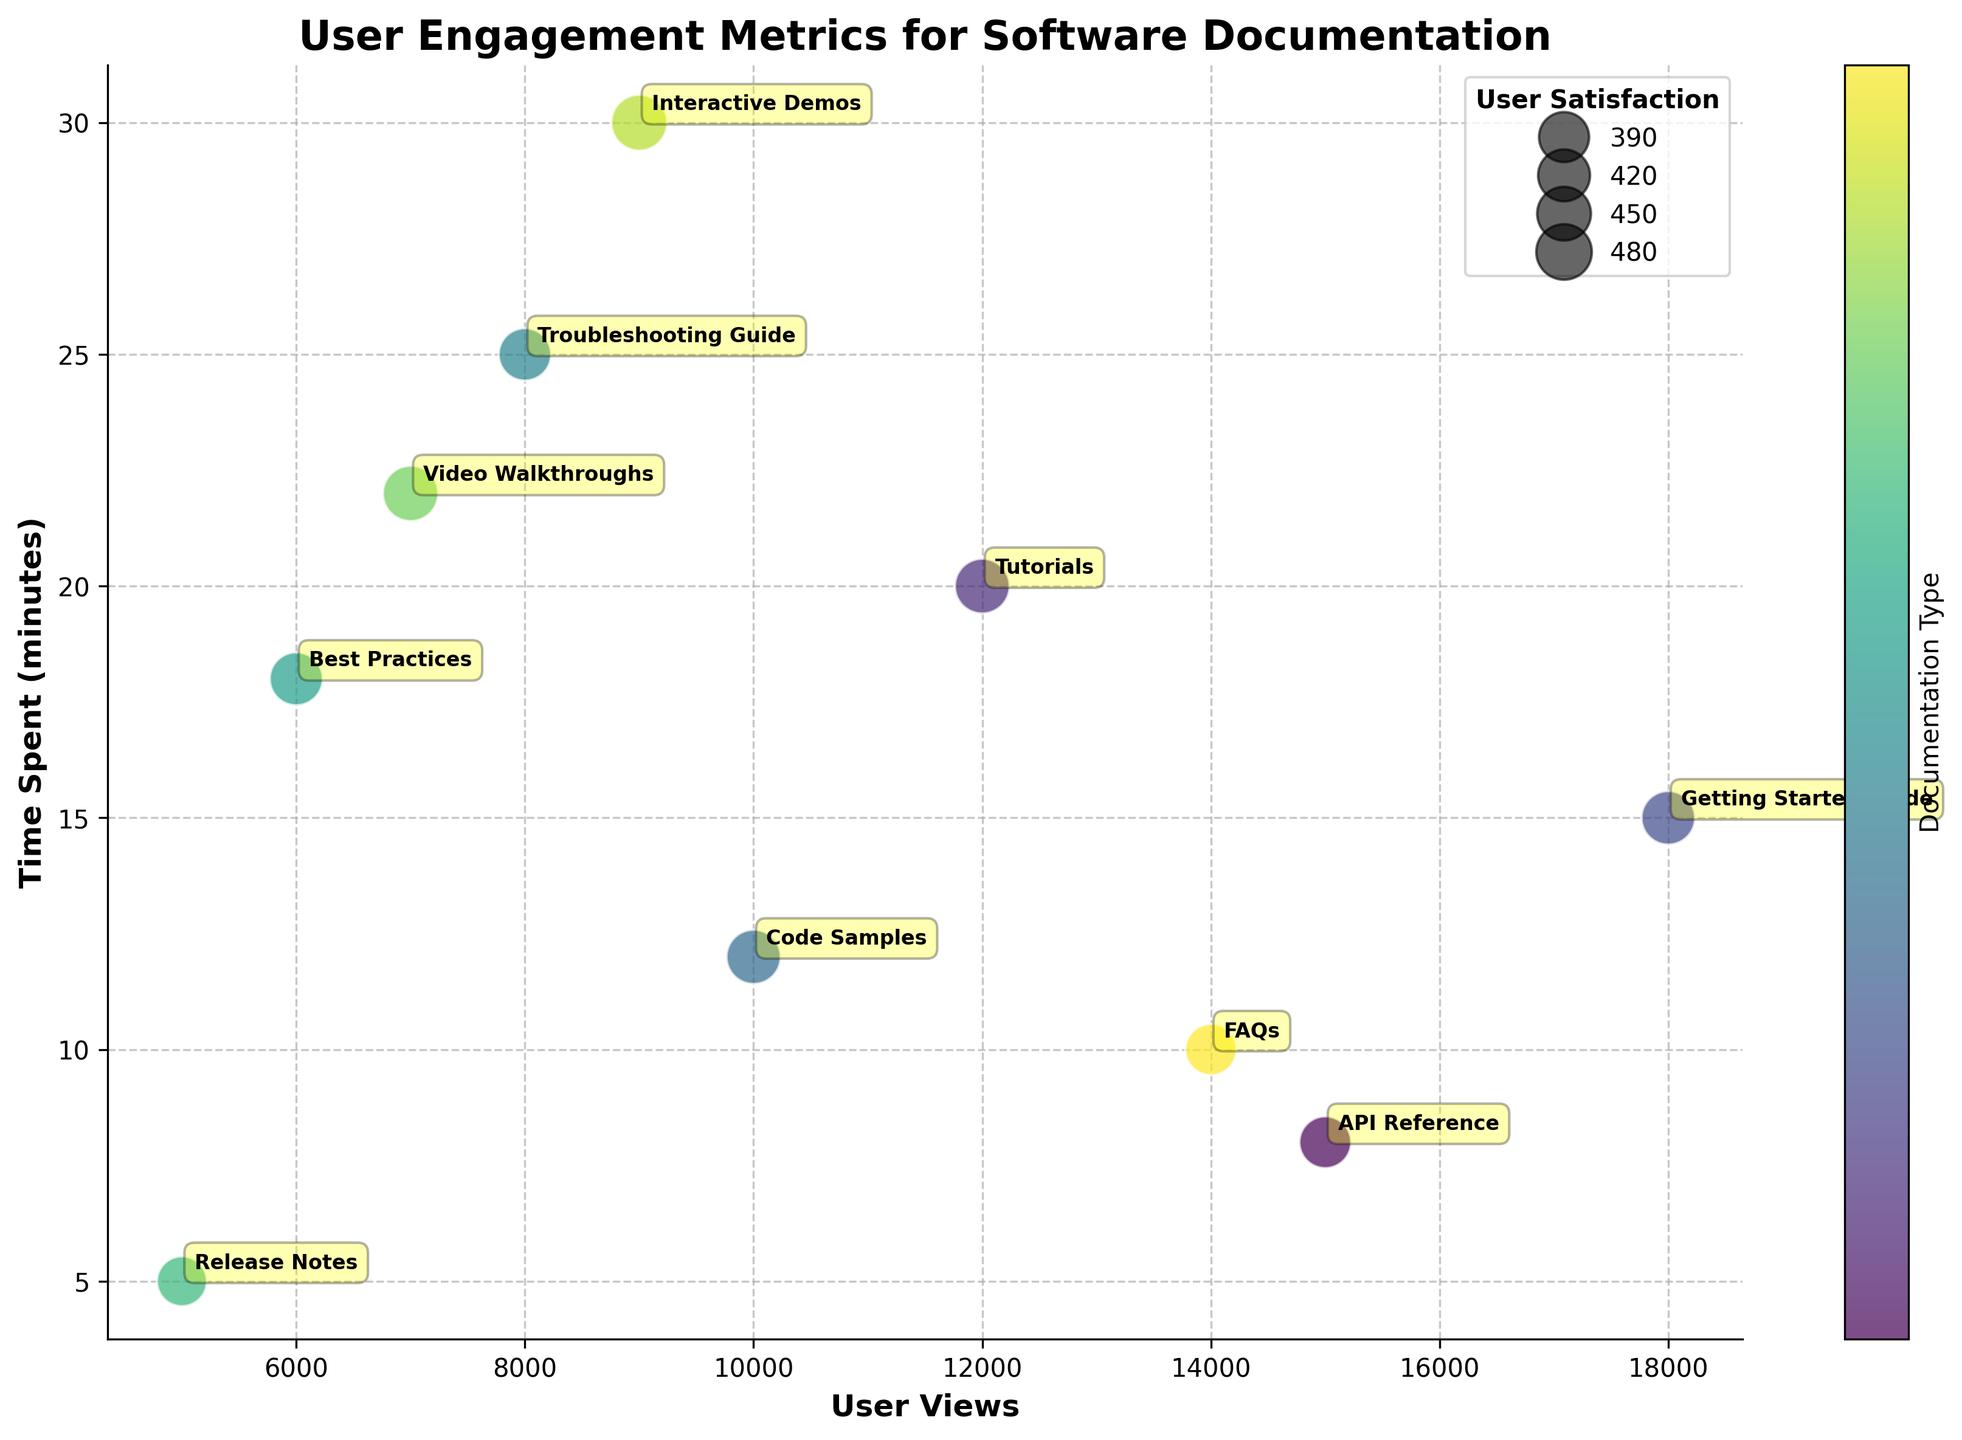What is the title of the figure? The title of the figure is usually found at the top and provides a summary of what the figure represents. In this case, the title "User Engagement Metrics for Software Documentation" is located at the top of the plot.
Answer: User Engagement Metrics for Software Documentation What does the size of each bubble represent? The size of each bubble corresponds to the user satisfaction scores. This is typically indicated by a key or legend within the chart that links bubble size to satisfaction level.
Answer: User satisfaction scores Which documentation type shows the highest user satisfaction score? To find the documentation type with the highest user satisfaction score, look for the largest bubble since size indicates user satisfaction. In this case, "Interactive Demos" appears to have the largest bubble.
Answer: Interactive Demos How does the time spent on "Tutorials" compare to the time spent on "Release Notes"? Locate the position of "Tutorials" and "Release Notes" bubbles along the Y-axis, which represents time spent in minutes. "Tutorials" is at 20 minutes, and "Release Notes" is at 5 minutes.
Answer: Tutorials have a higher time spent than Release Notes Which documentation type has the least user views but high user satisfaction? Find the bubble on the extreme left of the X-axis (User Views) that is also relatively large indicating high satisfaction. "Release Notes" has the least views (5000) and a moderate satisfaction score.
Answer: Release Notes What is the average time spent on "Getting Started Guide" and "Code Samples"? First, locate the "Getting Started Guide" at 15 minutes and "Code Samples" at 12 minutes. Sum their time spent values: 15 + 12 = 27 minutes. Then, divide by 2 to get the average: 27 / 2 = 13.5 minutes.
Answer: 13.5 minutes Which documentation has more user views, "API Reference" or "FAQs"? Check the X-axis position of "API Reference" (15000) and "FAQs" (14000), and compare their positions.
Answer: API Reference What pattern do you observe between user views and user satisfaction scores? Look at the chart to identify the relation of bubble size (user satisfaction score) against the X-axis (user views). Generally, bubbles with high user satisfaction are scattered across the range, not directly proportional to user views.
Answer: No clear pattern Identify the documentation type with the maximum time spent. Check the Y-axis for the uppermost bubble, which represents the maximum time spent. "Interactive Demos" tops the Y-axis with 30 minutes spent.
Answer: Interactive Demos 